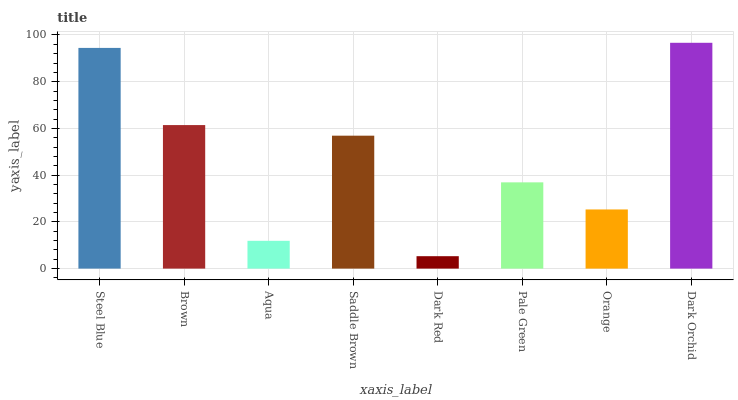Is Brown the minimum?
Answer yes or no. No. Is Brown the maximum?
Answer yes or no. No. Is Steel Blue greater than Brown?
Answer yes or no. Yes. Is Brown less than Steel Blue?
Answer yes or no. Yes. Is Brown greater than Steel Blue?
Answer yes or no. No. Is Steel Blue less than Brown?
Answer yes or no. No. Is Saddle Brown the high median?
Answer yes or no. Yes. Is Pale Green the low median?
Answer yes or no. Yes. Is Dark Orchid the high median?
Answer yes or no. No. Is Dark Orchid the low median?
Answer yes or no. No. 